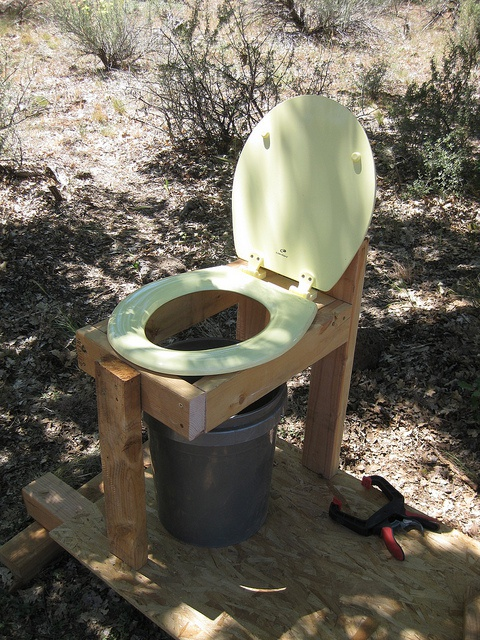Describe the objects in this image and their specific colors. I can see a toilet in white, darkgray, and beige tones in this image. 